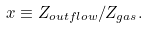Convert formula to latex. <formula><loc_0><loc_0><loc_500><loc_500>x \equiv Z _ { o u t f l o w } / Z _ { g a s } .</formula> 